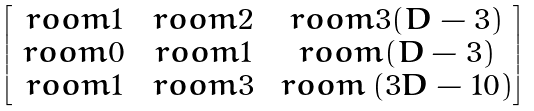<formula> <loc_0><loc_0><loc_500><loc_500>\begin{bmatrix} \ r o o m 1 & \ r o o m 2 & \ r o o m 3 ( D - 3 ) \\ \ r o o m 0 & \ r o o m 1 & \ r o o m ( D - 3 ) \\ \ r o o m 1 & \ r o o m 3 & \ r o o m \left ( 3 D - 1 0 \right ) \end{bmatrix}</formula> 